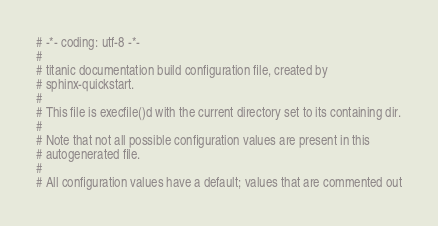<code> <loc_0><loc_0><loc_500><loc_500><_Python_># -*- coding: utf-8 -*-
#
# titanic documentation build configuration file, created by
# sphinx-quickstart.
#
# This file is execfile()d with the current directory set to its containing dir.
#
# Note that not all possible configuration values are present in this
# autogenerated file.
#
# All configuration values have a default; values that are commented out</code> 